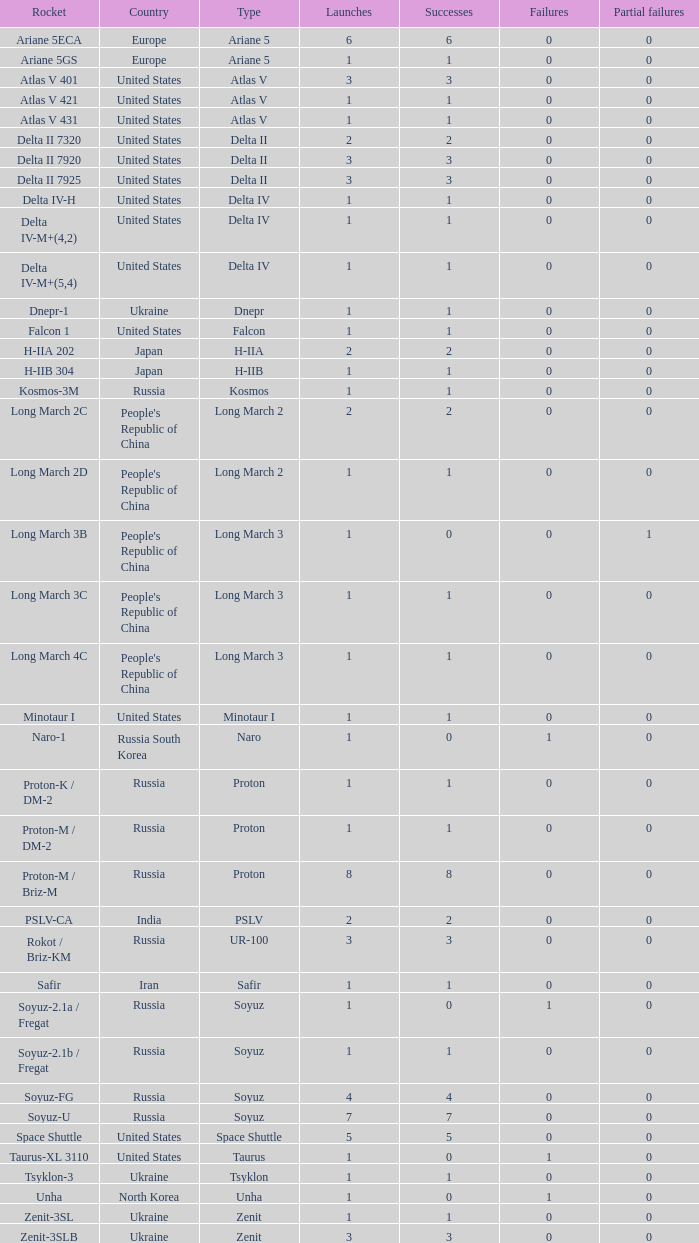What is the number of successes for rockets that have more than 3 launches, were based in Russia, are type soyuz and a rocket type of soyuz-u? 1.0. 